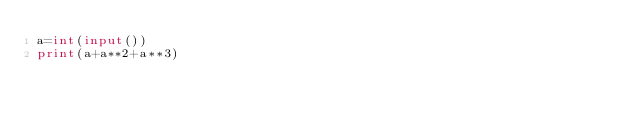<code> <loc_0><loc_0><loc_500><loc_500><_Python_>a=int(input())
print(a+a**2+a**3)</code> 